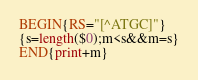Convert code to text. <code><loc_0><loc_0><loc_500><loc_500><_Awk_>BEGIN{RS="[^ATGC]"}
{s=length($0);m<s&&m=s}
END{print+m}</code> 